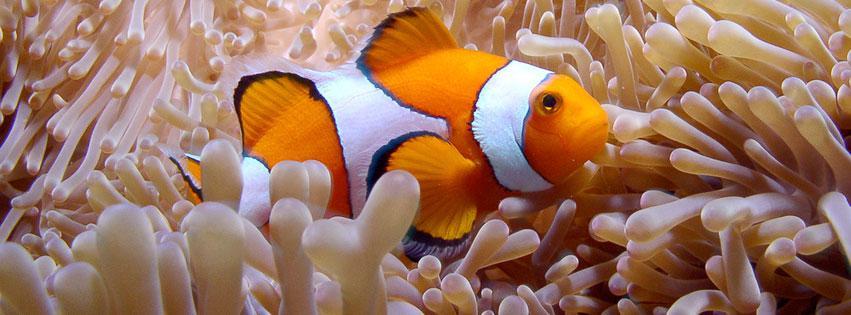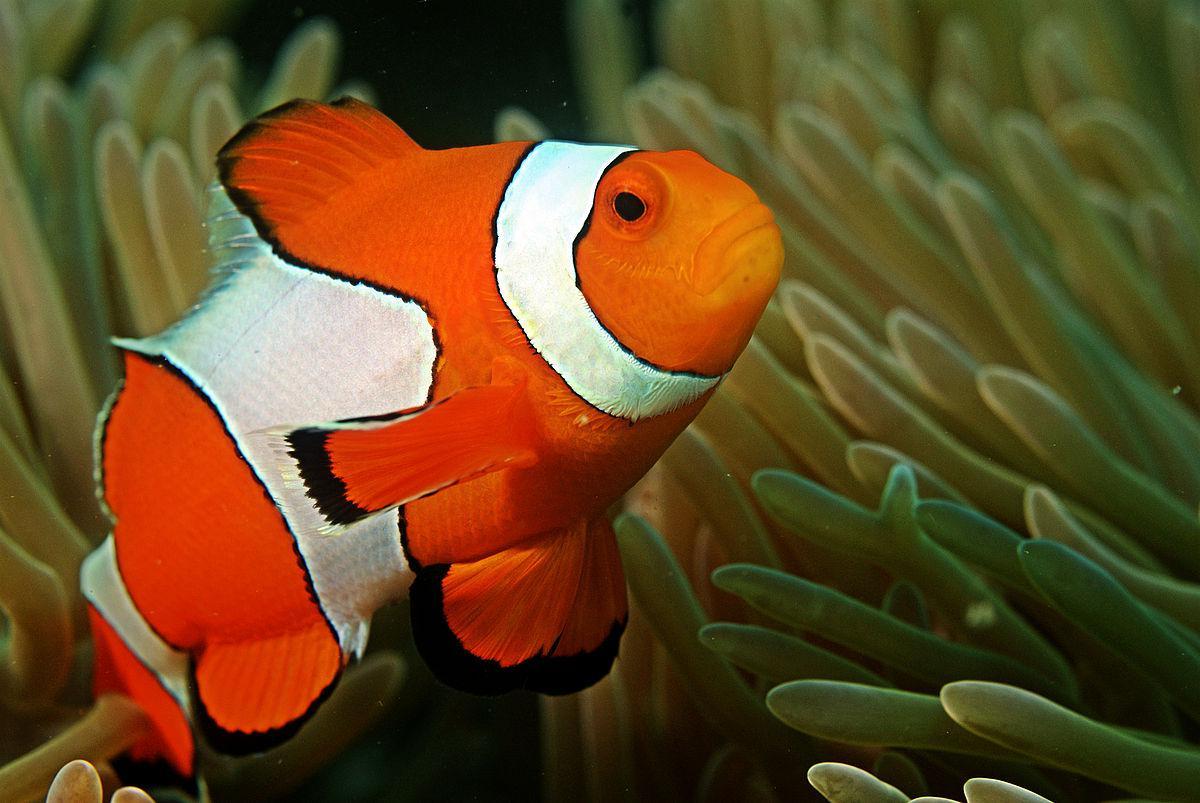The first image is the image on the left, the second image is the image on the right. Analyze the images presented: Is the assertion "There are three fish" valid? Answer yes or no. No. The first image is the image on the left, the second image is the image on the right. Assess this claim about the two images: "There is only one clownfish on the right image". Correct or not? Answer yes or no. Yes. 